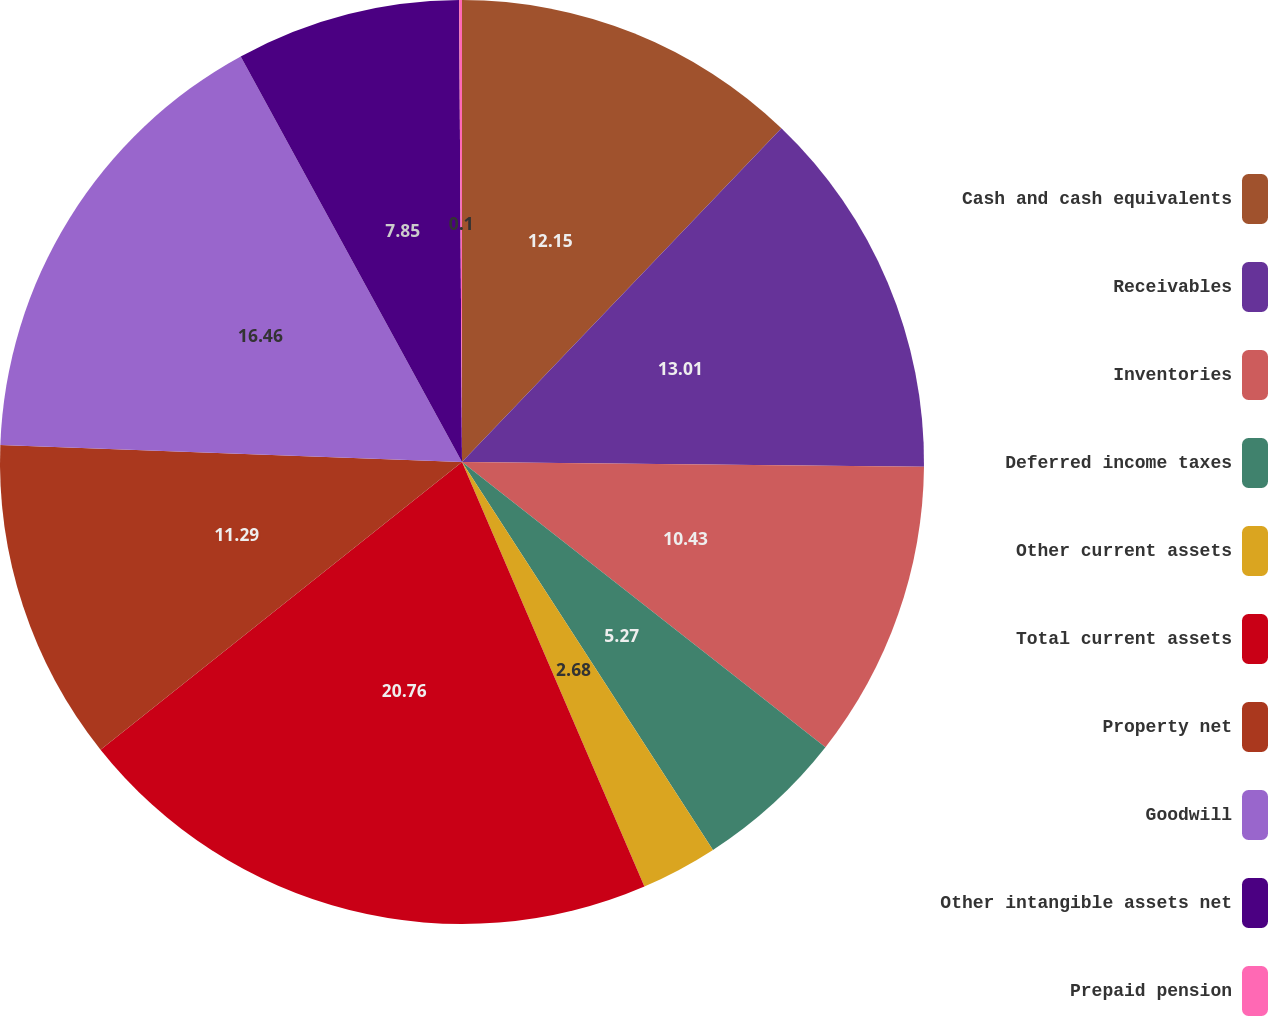Convert chart. <chart><loc_0><loc_0><loc_500><loc_500><pie_chart><fcel>Cash and cash equivalents<fcel>Receivables<fcel>Inventories<fcel>Deferred income taxes<fcel>Other current assets<fcel>Total current assets<fcel>Property net<fcel>Goodwill<fcel>Other intangible assets net<fcel>Prepaid pension<nl><fcel>12.15%<fcel>13.01%<fcel>10.43%<fcel>5.27%<fcel>2.68%<fcel>20.76%<fcel>11.29%<fcel>16.46%<fcel>7.85%<fcel>0.1%<nl></chart> 